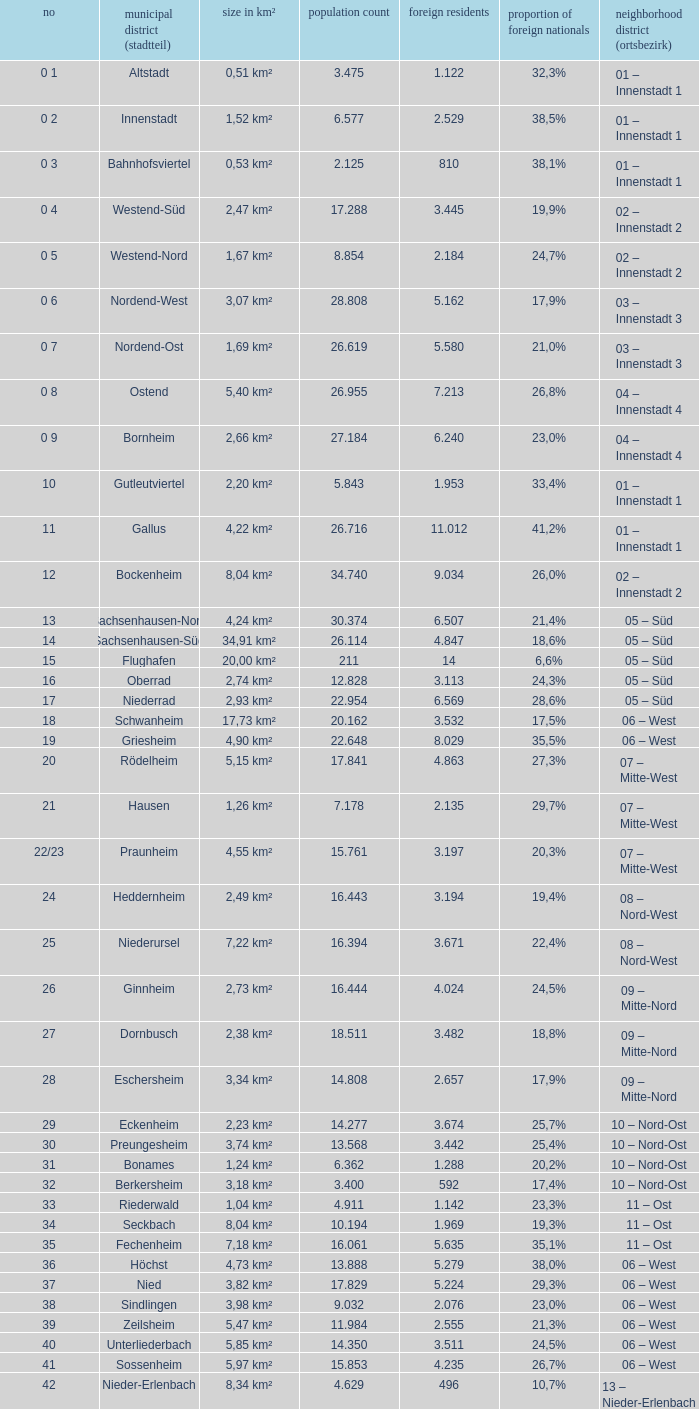What is the number of the city district of stadtteil where foreigners are 5.162? 1.0. 